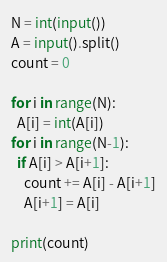<code> <loc_0><loc_0><loc_500><loc_500><_Python_>N = int(input())
A = input().split()
count = 0

for i in range(N):
  A[i] = int(A[i])
for i in range(N-1):
  if A[i] > A[i+1]:
    count += A[i] - A[i+1]
    A[i+1] = A[i]

print(count)</code> 